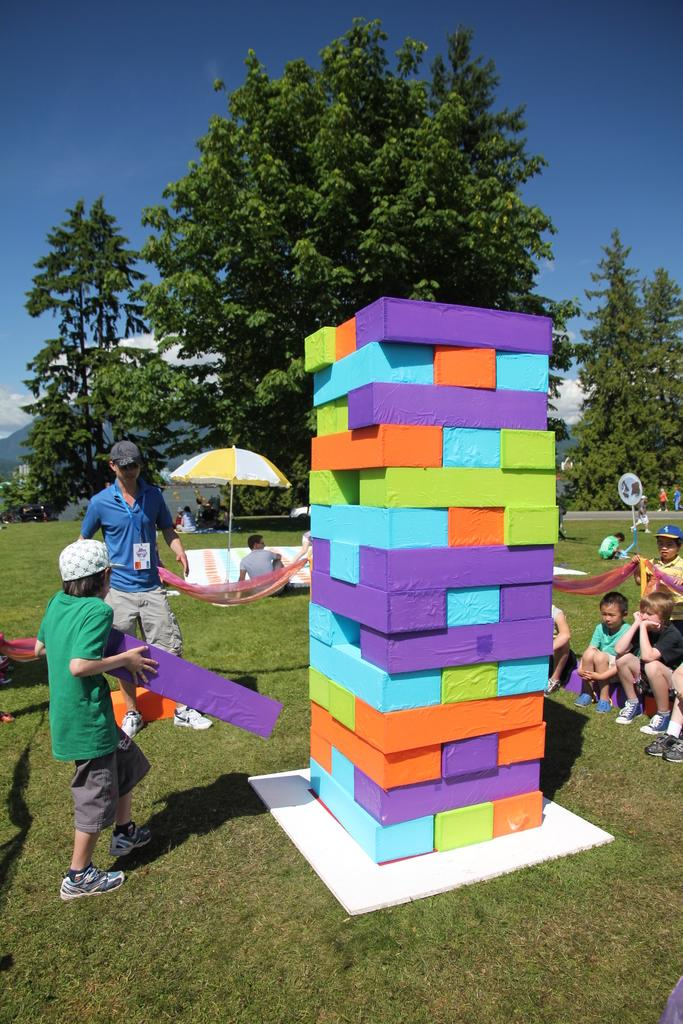What is the main object at the center of the image? There is a building block at the center of the image. Who is present in the image? Children are sitting on the grass. What can be seen in the background of the image? There are trees and the sky visible in the background of the image. What type of sign can be seen in the image? There is no sign present in the image. What experience are the children having while sitting on the grass? The image does not provide information about the children's experience; it only shows them sitting on the grass. 